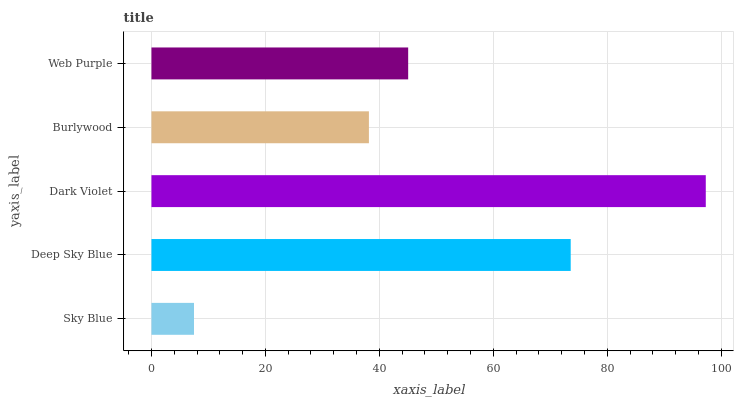Is Sky Blue the minimum?
Answer yes or no. Yes. Is Dark Violet the maximum?
Answer yes or no. Yes. Is Deep Sky Blue the minimum?
Answer yes or no. No. Is Deep Sky Blue the maximum?
Answer yes or no. No. Is Deep Sky Blue greater than Sky Blue?
Answer yes or no. Yes. Is Sky Blue less than Deep Sky Blue?
Answer yes or no. Yes. Is Sky Blue greater than Deep Sky Blue?
Answer yes or no. No. Is Deep Sky Blue less than Sky Blue?
Answer yes or no. No. Is Web Purple the high median?
Answer yes or no. Yes. Is Web Purple the low median?
Answer yes or no. Yes. Is Sky Blue the high median?
Answer yes or no. No. Is Deep Sky Blue the low median?
Answer yes or no. No. 